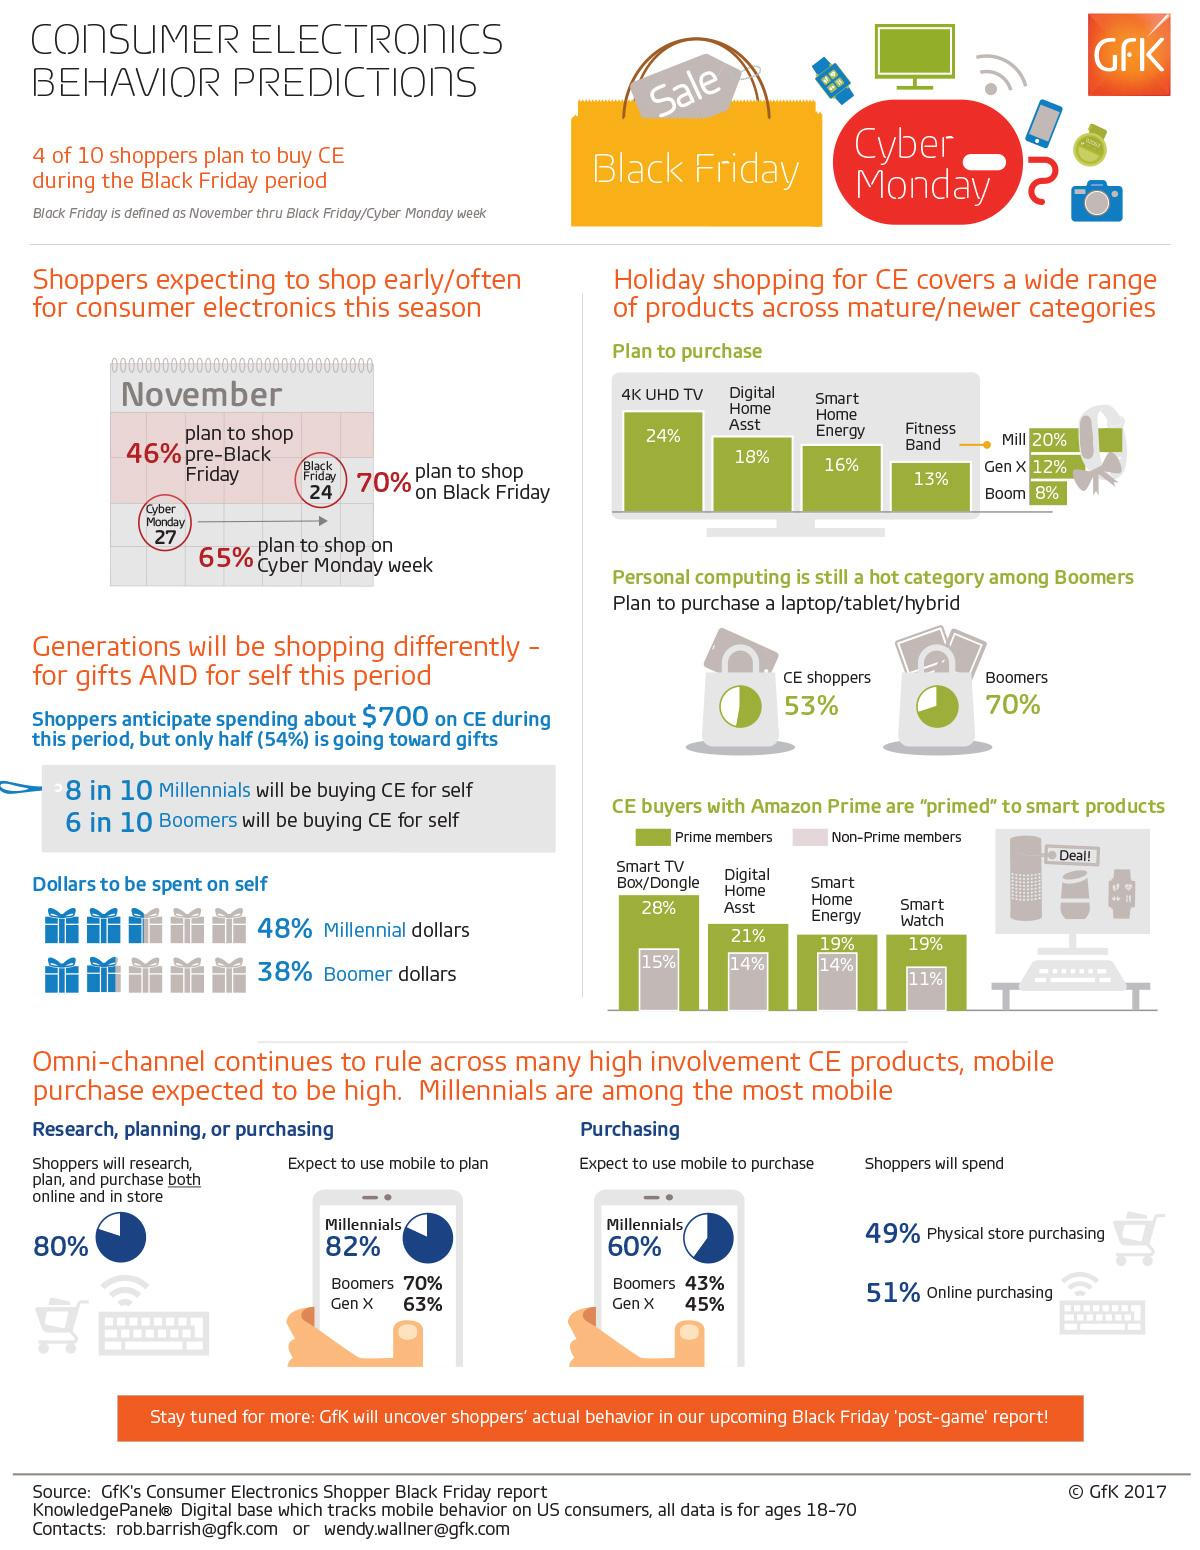Specify some key components in this picture. A 7% difference in digital home asset purchasing behavior exists between prime and non-prime users. The majority of individuals are likely to purchase 4K UHD TVs during the holiday season. According to a recent study, 19% of Amazon Prime users also purchase Smart home energy or Smart watch products. According to a survey, 70% of Baby Boomers plan to purchase a computing gadget in the near future. Millennials are the generation that spends the most money on themselves. 